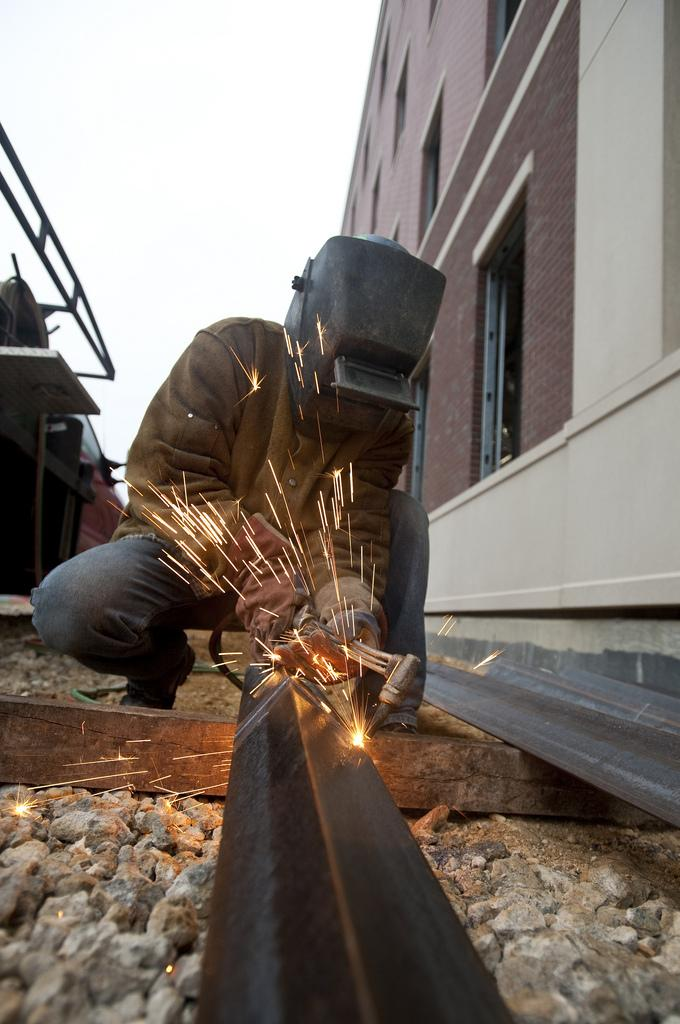What is the person in the image doing? The person is welding an iron rod in the image. What structure is located on the left side of the image? There is a house on the left side of the image. What objects are on the right side of the image? There are tables on the right side of the image. What can be seen in the background of the image? The sky is visible in the background of the image. What thought is the person having while welding in the image? There is no indication of the person's thoughts in the image, as we cannot see their facial expression or read their mind. 